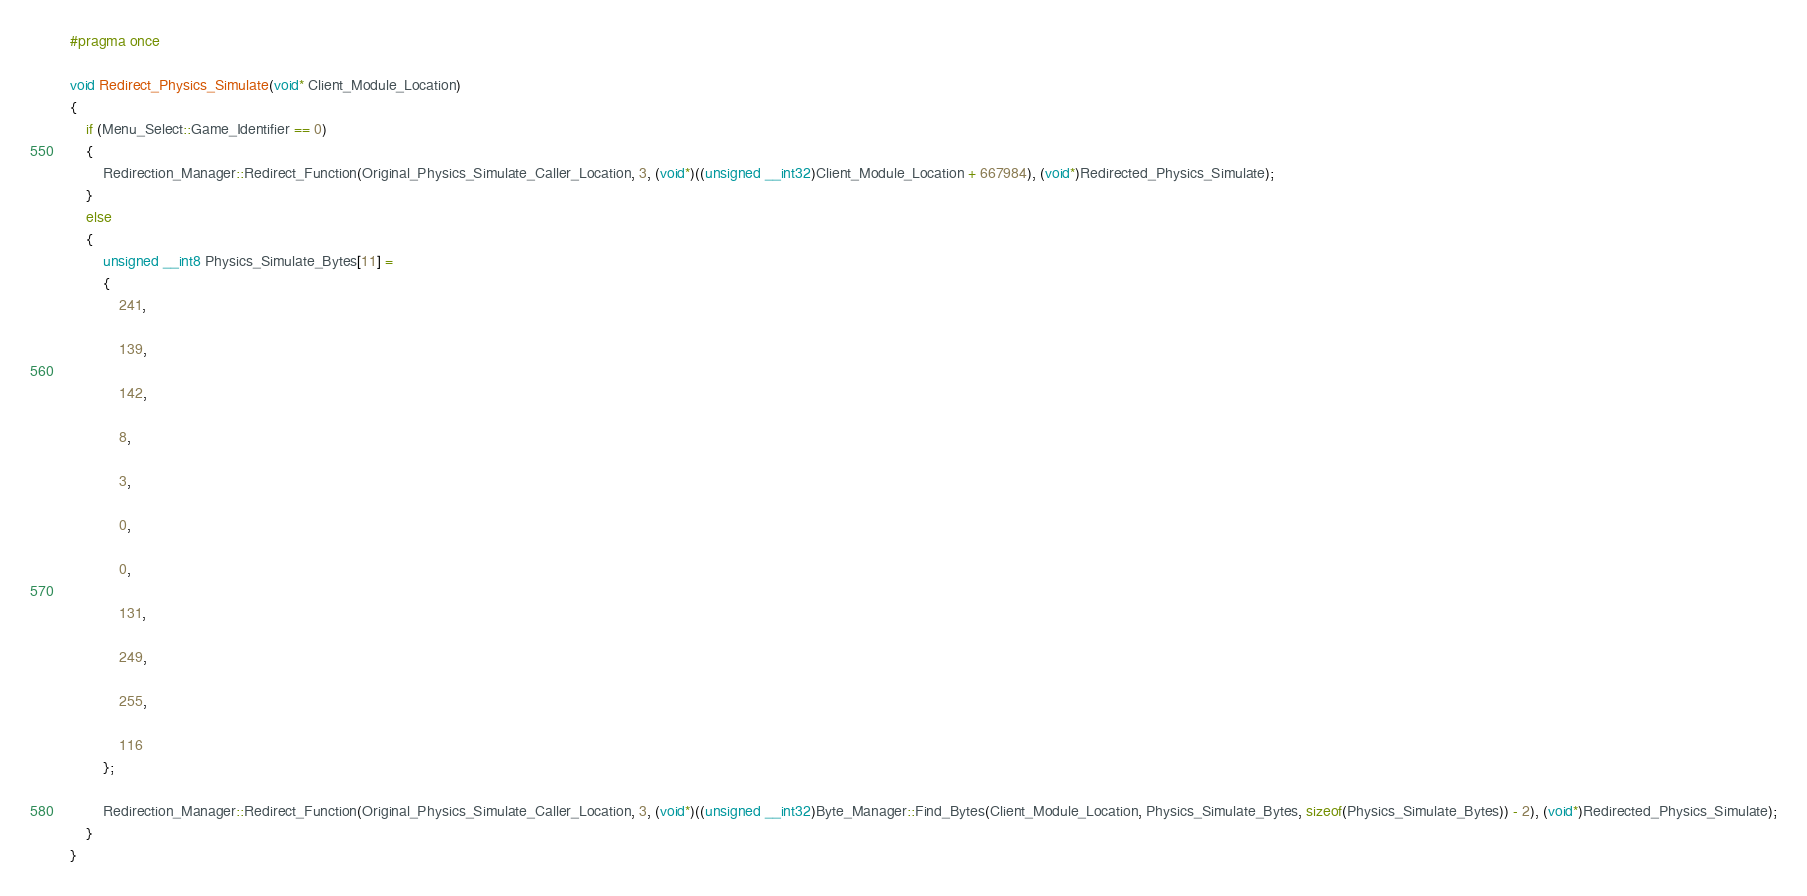Convert code to text. <code><loc_0><loc_0><loc_500><loc_500><_C++_>#pragma once

void Redirect_Physics_Simulate(void* Client_Module_Location)
{
	if (Menu_Select::Game_Identifier == 0)
	{
		Redirection_Manager::Redirect_Function(Original_Physics_Simulate_Caller_Location, 3, (void*)((unsigned __int32)Client_Module_Location + 667984), (void*)Redirected_Physics_Simulate);
	}
	else
	{
		unsigned __int8 Physics_Simulate_Bytes[11] =
		{
			241,

			139,

			142,

			8,

			3,

			0,

			0,

			131,

			249,

			255,

			116
		};

		Redirection_Manager::Redirect_Function(Original_Physics_Simulate_Caller_Location, 3, (void*)((unsigned __int32)Byte_Manager::Find_Bytes(Client_Module_Location, Physics_Simulate_Bytes, sizeof(Physics_Simulate_Bytes)) - 2), (void*)Redirected_Physics_Simulate);
	}
}</code> 